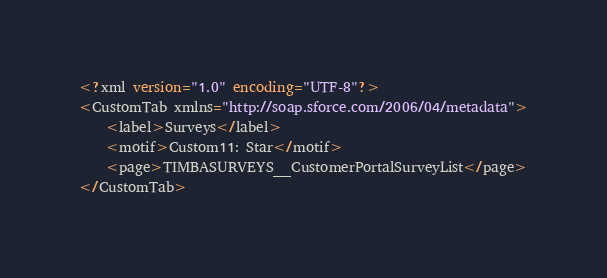Convert code to text. <code><loc_0><loc_0><loc_500><loc_500><_SQL_><?xml version="1.0" encoding="UTF-8"?>
<CustomTab xmlns="http://soap.sforce.com/2006/04/metadata">
    <label>Surveys</label>
    <motif>Custom11: Star</motif>
    <page>TIMBASURVEYS__CustomerPortalSurveyList</page>
</CustomTab>
</code> 